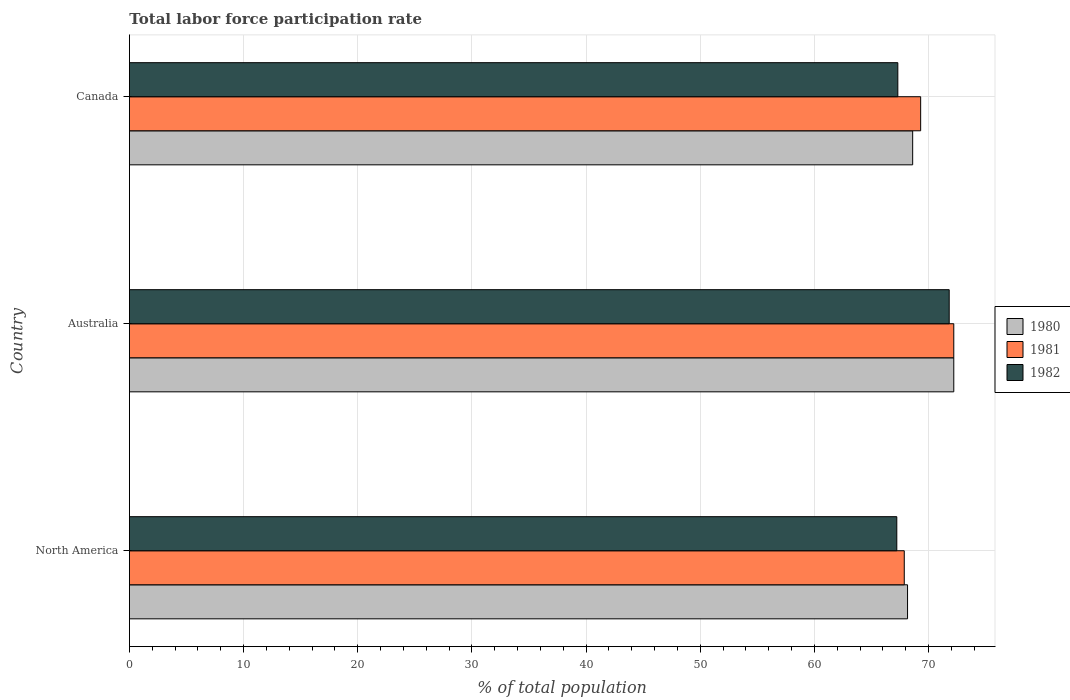How many different coloured bars are there?
Your answer should be very brief. 3. How many groups of bars are there?
Ensure brevity in your answer.  3. How many bars are there on the 3rd tick from the bottom?
Offer a very short reply. 3. What is the total labor force participation rate in 1982 in Australia?
Offer a terse response. 71.8. Across all countries, what is the maximum total labor force participation rate in 1980?
Offer a terse response. 72.2. Across all countries, what is the minimum total labor force participation rate in 1980?
Ensure brevity in your answer.  68.15. What is the total total labor force participation rate in 1981 in the graph?
Make the answer very short. 209.36. What is the difference between the total labor force participation rate in 1981 in Australia and that in North America?
Your answer should be compact. 4.34. What is the difference between the total labor force participation rate in 1982 in North America and the total labor force participation rate in 1981 in Canada?
Offer a terse response. -2.09. What is the average total labor force participation rate in 1981 per country?
Ensure brevity in your answer.  69.79. What is the difference between the total labor force participation rate in 1981 and total labor force participation rate in 1982 in North America?
Give a very brief answer. 0.65. In how many countries, is the total labor force participation rate in 1980 greater than 72 %?
Keep it short and to the point. 1. What is the ratio of the total labor force participation rate in 1980 in Canada to that in North America?
Keep it short and to the point. 1.01. Is the difference between the total labor force participation rate in 1981 in Australia and Canada greater than the difference between the total labor force participation rate in 1982 in Australia and Canada?
Your response must be concise. No. What is the difference between the highest and the second highest total labor force participation rate in 1982?
Your answer should be compact. 4.5. What is the difference between the highest and the lowest total labor force participation rate in 1982?
Your answer should be compact. 4.59. Is the sum of the total labor force participation rate in 1981 in Australia and North America greater than the maximum total labor force participation rate in 1980 across all countries?
Offer a terse response. Yes. How many bars are there?
Your answer should be very brief. 9. Are all the bars in the graph horizontal?
Ensure brevity in your answer.  Yes. How many countries are there in the graph?
Ensure brevity in your answer.  3. What is the difference between two consecutive major ticks on the X-axis?
Provide a short and direct response. 10. Where does the legend appear in the graph?
Your answer should be compact. Center right. How are the legend labels stacked?
Keep it short and to the point. Vertical. What is the title of the graph?
Keep it short and to the point. Total labor force participation rate. Does "1993" appear as one of the legend labels in the graph?
Ensure brevity in your answer.  No. What is the label or title of the X-axis?
Make the answer very short. % of total population. What is the % of total population in 1980 in North America?
Offer a terse response. 68.15. What is the % of total population in 1981 in North America?
Your answer should be very brief. 67.86. What is the % of total population in 1982 in North America?
Ensure brevity in your answer.  67.21. What is the % of total population in 1980 in Australia?
Give a very brief answer. 72.2. What is the % of total population in 1981 in Australia?
Provide a short and direct response. 72.2. What is the % of total population of 1982 in Australia?
Provide a short and direct response. 71.8. What is the % of total population in 1980 in Canada?
Offer a terse response. 68.6. What is the % of total population in 1981 in Canada?
Make the answer very short. 69.3. What is the % of total population in 1982 in Canada?
Give a very brief answer. 67.3. Across all countries, what is the maximum % of total population in 1980?
Provide a short and direct response. 72.2. Across all countries, what is the maximum % of total population in 1981?
Ensure brevity in your answer.  72.2. Across all countries, what is the maximum % of total population of 1982?
Your response must be concise. 71.8. Across all countries, what is the minimum % of total population in 1980?
Ensure brevity in your answer.  68.15. Across all countries, what is the minimum % of total population of 1981?
Provide a succinct answer. 67.86. Across all countries, what is the minimum % of total population in 1982?
Provide a short and direct response. 67.21. What is the total % of total population in 1980 in the graph?
Provide a short and direct response. 208.95. What is the total % of total population in 1981 in the graph?
Give a very brief answer. 209.36. What is the total % of total population in 1982 in the graph?
Your answer should be compact. 206.31. What is the difference between the % of total population in 1980 in North America and that in Australia?
Keep it short and to the point. -4.05. What is the difference between the % of total population in 1981 in North America and that in Australia?
Offer a very short reply. -4.34. What is the difference between the % of total population of 1982 in North America and that in Australia?
Your answer should be compact. -4.59. What is the difference between the % of total population in 1980 in North America and that in Canada?
Your answer should be very brief. -0.45. What is the difference between the % of total population of 1981 in North America and that in Canada?
Provide a short and direct response. -1.44. What is the difference between the % of total population of 1982 in North America and that in Canada?
Your response must be concise. -0.09. What is the difference between the % of total population in 1980 in Australia and that in Canada?
Your answer should be very brief. 3.6. What is the difference between the % of total population in 1980 in North America and the % of total population in 1981 in Australia?
Your answer should be compact. -4.05. What is the difference between the % of total population of 1980 in North America and the % of total population of 1982 in Australia?
Provide a succinct answer. -3.65. What is the difference between the % of total population of 1981 in North America and the % of total population of 1982 in Australia?
Offer a terse response. -3.94. What is the difference between the % of total population in 1980 in North America and the % of total population in 1981 in Canada?
Make the answer very short. -1.15. What is the difference between the % of total population of 1980 in North America and the % of total population of 1982 in Canada?
Keep it short and to the point. 0.85. What is the difference between the % of total population of 1981 in North America and the % of total population of 1982 in Canada?
Provide a short and direct response. 0.56. What is the difference between the % of total population in 1980 in Australia and the % of total population in 1982 in Canada?
Provide a short and direct response. 4.9. What is the difference between the % of total population of 1981 in Australia and the % of total population of 1982 in Canada?
Your answer should be very brief. 4.9. What is the average % of total population in 1980 per country?
Make the answer very short. 69.65. What is the average % of total population of 1981 per country?
Make the answer very short. 69.79. What is the average % of total population in 1982 per country?
Ensure brevity in your answer.  68.77. What is the difference between the % of total population in 1980 and % of total population in 1981 in North America?
Your response must be concise. 0.29. What is the difference between the % of total population of 1980 and % of total population of 1982 in North America?
Make the answer very short. 0.94. What is the difference between the % of total population in 1981 and % of total population in 1982 in North America?
Provide a succinct answer. 0.65. What is the difference between the % of total population of 1980 and % of total population of 1981 in Australia?
Your response must be concise. 0. What is the difference between the % of total population of 1981 and % of total population of 1982 in Australia?
Provide a short and direct response. 0.4. What is the difference between the % of total population in 1980 and % of total population in 1981 in Canada?
Your answer should be compact. -0.7. What is the difference between the % of total population of 1981 and % of total population of 1982 in Canada?
Make the answer very short. 2. What is the ratio of the % of total population of 1980 in North America to that in Australia?
Provide a short and direct response. 0.94. What is the ratio of the % of total population of 1981 in North America to that in Australia?
Offer a very short reply. 0.94. What is the ratio of the % of total population of 1982 in North America to that in Australia?
Your answer should be compact. 0.94. What is the ratio of the % of total population of 1980 in North America to that in Canada?
Offer a very short reply. 0.99. What is the ratio of the % of total population of 1981 in North America to that in Canada?
Your response must be concise. 0.98. What is the ratio of the % of total population of 1982 in North America to that in Canada?
Give a very brief answer. 1. What is the ratio of the % of total population of 1980 in Australia to that in Canada?
Give a very brief answer. 1.05. What is the ratio of the % of total population of 1981 in Australia to that in Canada?
Offer a terse response. 1.04. What is the ratio of the % of total population in 1982 in Australia to that in Canada?
Your response must be concise. 1.07. What is the difference between the highest and the second highest % of total population of 1980?
Give a very brief answer. 3.6. What is the difference between the highest and the second highest % of total population in 1981?
Offer a very short reply. 2.9. What is the difference between the highest and the lowest % of total population in 1980?
Ensure brevity in your answer.  4.05. What is the difference between the highest and the lowest % of total population in 1981?
Give a very brief answer. 4.34. What is the difference between the highest and the lowest % of total population in 1982?
Offer a terse response. 4.59. 